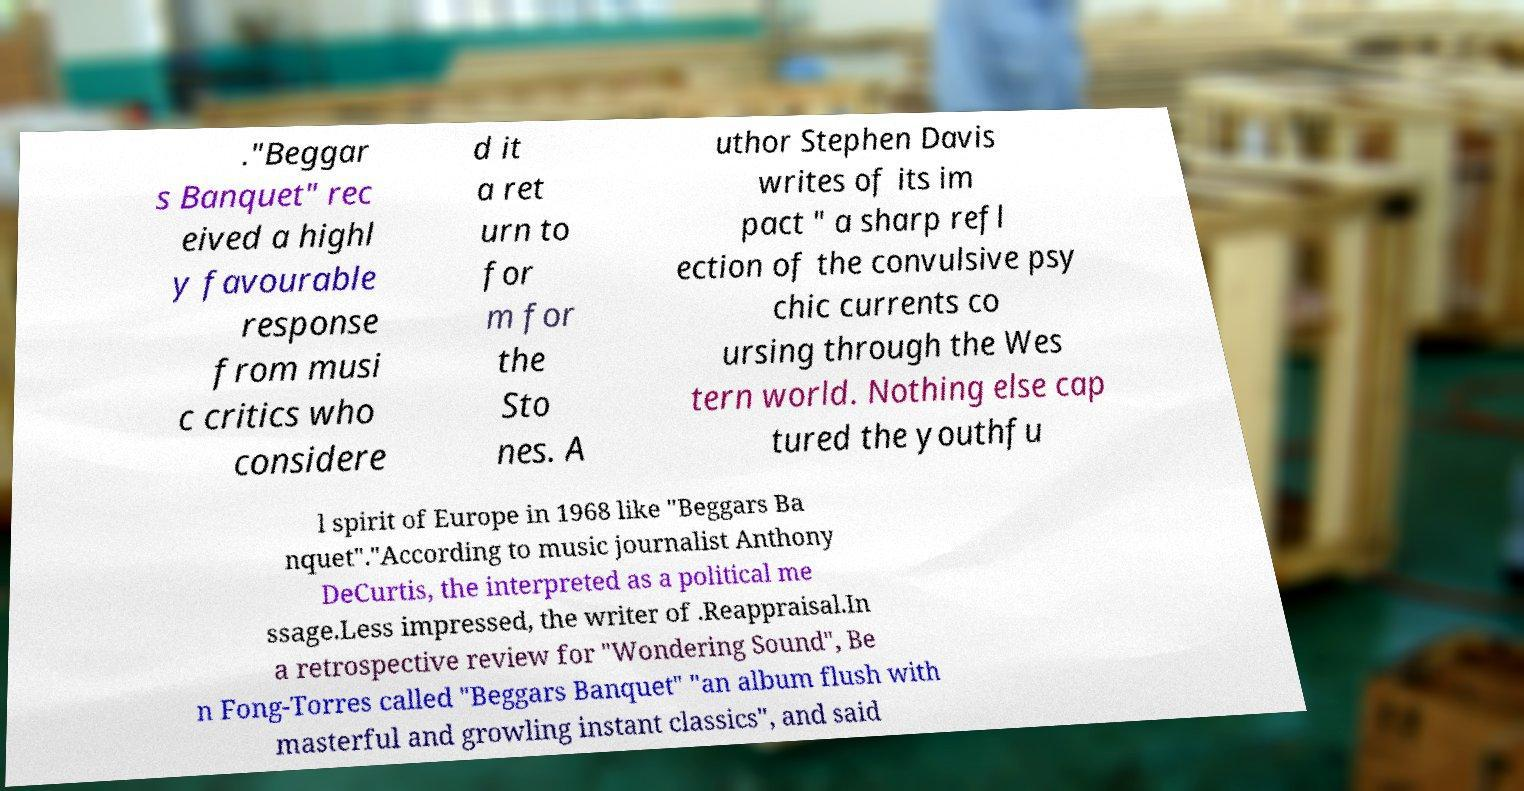I need the written content from this picture converted into text. Can you do that? ."Beggar s Banquet" rec eived a highl y favourable response from musi c critics who considere d it a ret urn to for m for the Sto nes. A uthor Stephen Davis writes of its im pact " a sharp refl ection of the convulsive psy chic currents co ursing through the Wes tern world. Nothing else cap tured the youthfu l spirit of Europe in 1968 like "Beggars Ba nquet"."According to music journalist Anthony DeCurtis, the interpreted as a political me ssage.Less impressed, the writer of .Reappraisal.In a retrospective review for "Wondering Sound", Be n Fong-Torres called "Beggars Banquet" "an album flush with masterful and growling instant classics", and said 